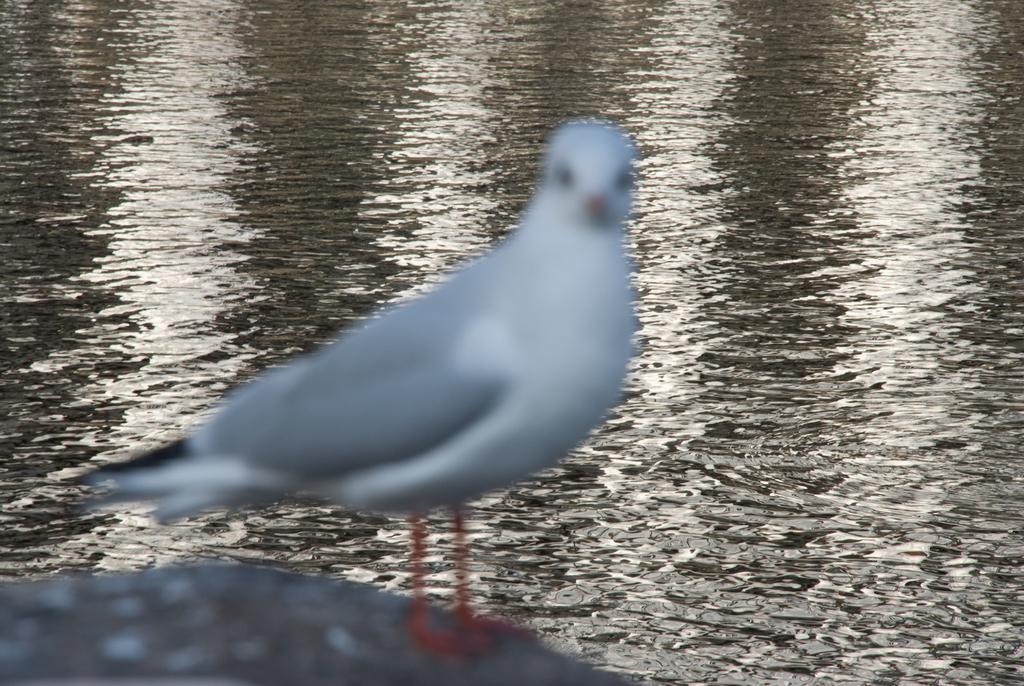Please provide a concise description of this image. This picture is clicked outside. In the foreground we can see a bird seems to be standing on the ground. In the background we can see a water body. 